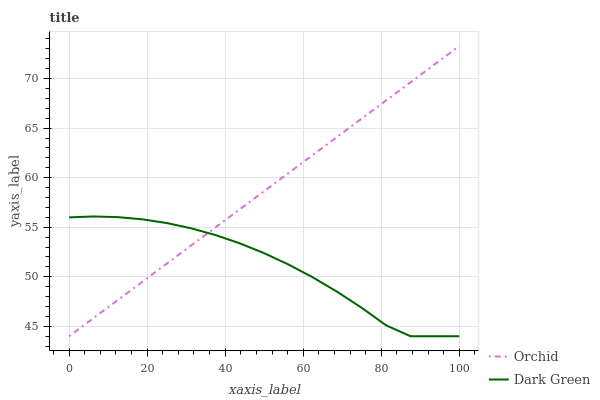Does Orchid have the minimum area under the curve?
Answer yes or no. No. Is Orchid the roughest?
Answer yes or no. No. 